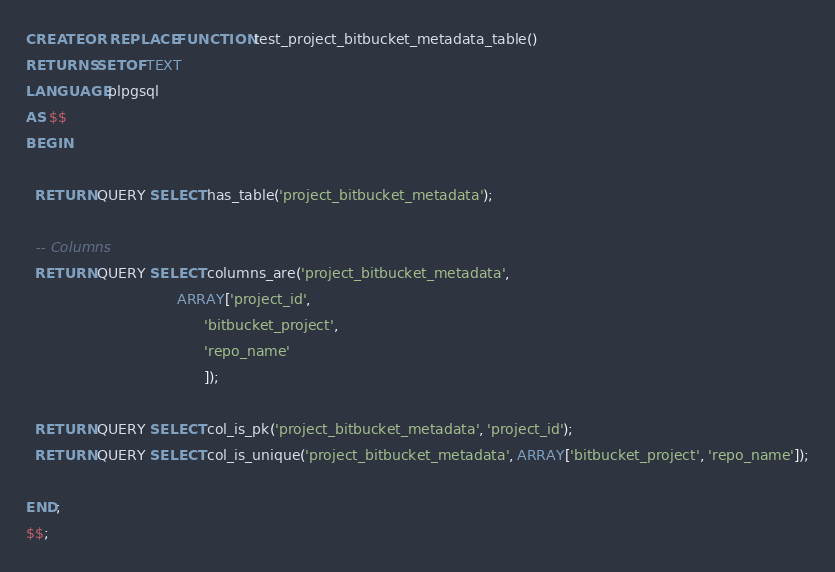Convert code to text. <code><loc_0><loc_0><loc_500><loc_500><_SQL_>CREATE OR REPLACE FUNCTION test_project_bitbucket_metadata_table()
RETURNS SETOF TEXT
LANGUAGE plpgsql
AS $$
BEGIN

  RETURN QUERY SELECT has_table('project_bitbucket_metadata');

  -- Columns
  RETURN QUERY SELECT columns_are('project_bitbucket_metadata',
                                  ARRAY['project_id',
                                        'bitbucket_project',
                                        'repo_name'
                                        ]);

  RETURN QUERY SELECT col_is_pk('project_bitbucket_metadata', 'project_id');
  RETURN QUERY SELECT col_is_unique('project_bitbucket_metadata', ARRAY['bitbucket_project', 'repo_name']);

END;
$$;
</code> 